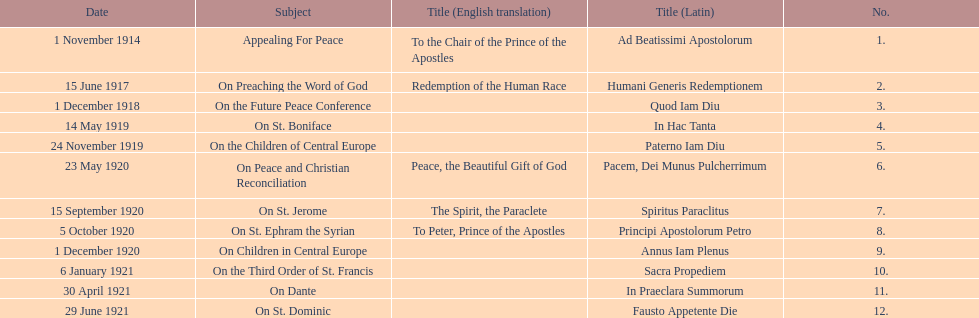What is the first english translation listed on the table? To the Chair of the Prince of the Apostles. 